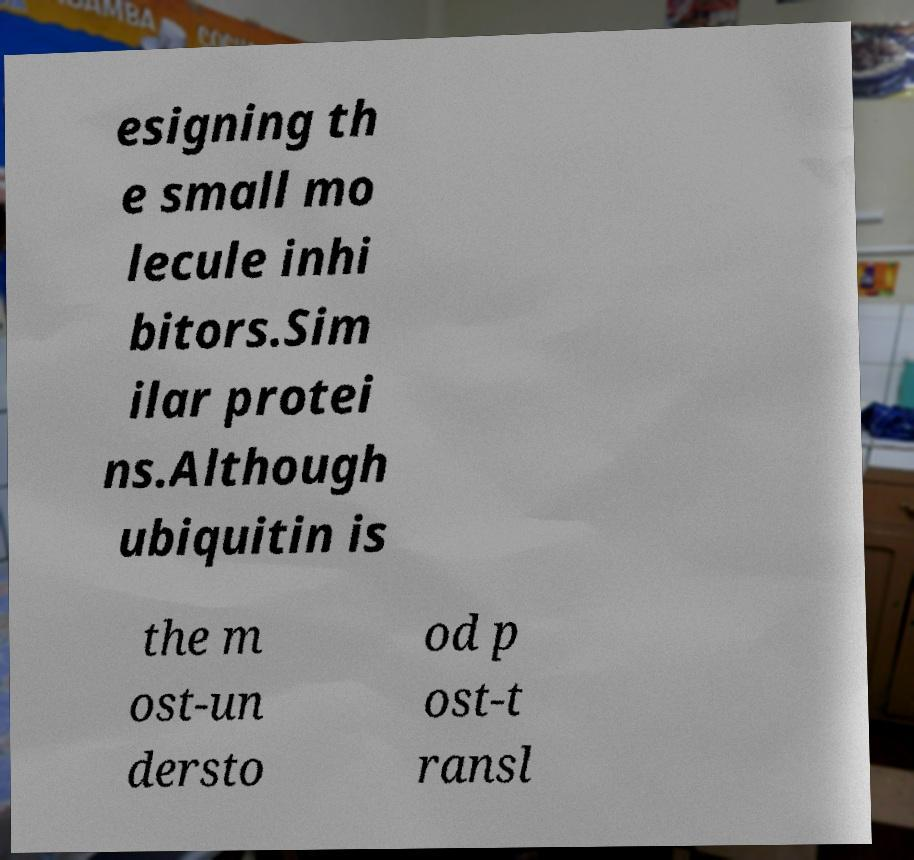Can you read and provide the text displayed in the image?This photo seems to have some interesting text. Can you extract and type it out for me? esigning th e small mo lecule inhi bitors.Sim ilar protei ns.Although ubiquitin is the m ost-un dersto od p ost-t ransl 